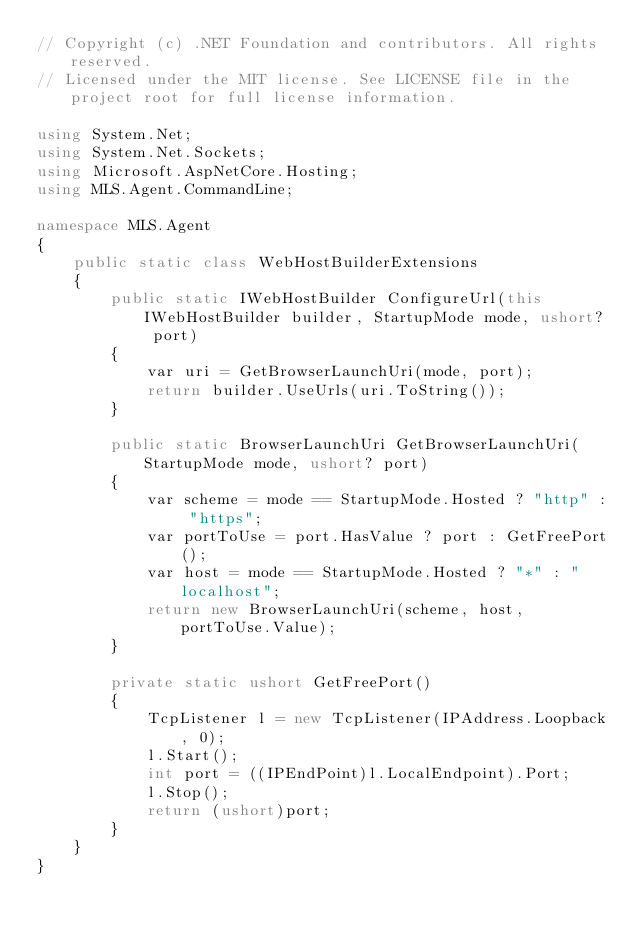<code> <loc_0><loc_0><loc_500><loc_500><_C#_>// Copyright (c) .NET Foundation and contributors. All rights reserved.
// Licensed under the MIT license. See LICENSE file in the project root for full license information.

using System.Net;
using System.Net.Sockets;
using Microsoft.AspNetCore.Hosting;
using MLS.Agent.CommandLine;

namespace MLS.Agent
{
    public static class WebHostBuilderExtensions
    {
        public static IWebHostBuilder ConfigureUrl(this IWebHostBuilder builder, StartupMode mode, ushort? port)
        {
            var uri = GetBrowserLaunchUri(mode, port);
            return builder.UseUrls(uri.ToString());
        }

        public static BrowserLaunchUri GetBrowserLaunchUri(StartupMode mode, ushort? port)
        {
            var scheme = mode == StartupMode.Hosted ? "http" : "https";
            var portToUse = port.HasValue ? port : GetFreePort();
            var host = mode == StartupMode.Hosted ? "*" : "localhost";
            return new BrowserLaunchUri(scheme, host, portToUse.Value);
        }

        private static ushort GetFreePort()
        {
            TcpListener l = new TcpListener(IPAddress.Loopback, 0);
            l.Start();
            int port = ((IPEndPoint)l.LocalEndpoint).Port;
            l.Stop();
            return (ushort)port;
        }
    }
}</code> 